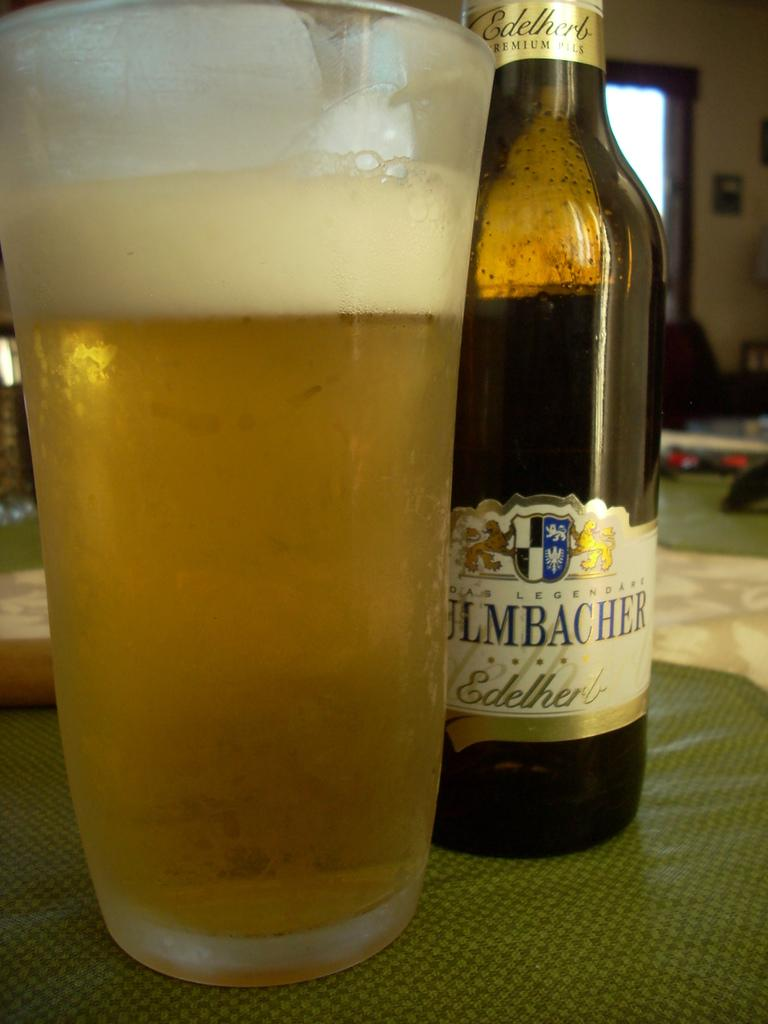<image>
Describe the image concisely. A bottle of Ulmbacher has been poured into a glass 